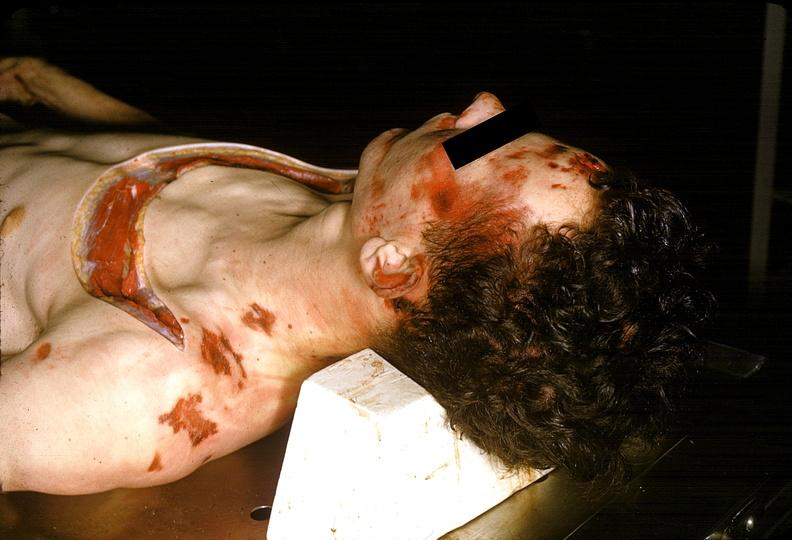what does this image show?
Answer the question using a single word or phrase. Severe trauma 